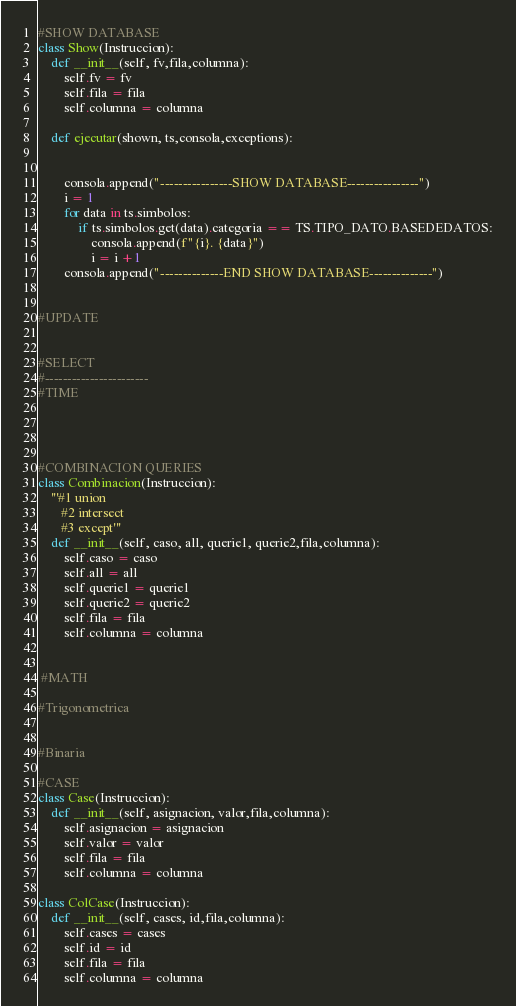<code> <loc_0><loc_0><loc_500><loc_500><_Python_>

#SHOW DATABASE
class Show(Instruccion):
    def __init__(self, fv,fila,columna):
        self.fv = fv
        self.fila = fila
        self.columna = columna

    def ejecutar(shown, ts,consola,exceptions):


        consola.append("----------------SHOW DATABASE----------------")
        i = 1
        for data in ts.simbolos:
            if ts.simbolos.get(data).categoria == TS.TIPO_DATO.BASEDEDATOS:
                consola.append(f"{i}. {data}")
                i = i +1
        consola.append("--------------END SHOW DATABASE--------------")


#UPDATE


#SELECT
#-----------------------
#TIME




#COMBINACION QUERIES
class Combinacion(Instruccion):
    '''#1 union
       #2 intersect
       #3 except'''
    def __init__(self, caso, all, querie1, querie2,fila,columna):
        self.caso = caso
        self.all = all
        self.querie1 = querie1
        self.querie2 = querie2
        self.fila = fila
        self.columna = columna


 #MATH

#Trigonometrica


#Binaria

#CASE
class Case(Instruccion):
    def __init__(self, asignacion, valor,fila,columna):
        self.asignacion = asignacion
        self.valor = valor
        self.fila = fila
        self.columna = columna

class ColCase(Instruccion):
    def __init__(self, cases, id,fila,columna):
        self.cases = cases
        self.id = id
        self.fila = fila
        self.columna = columna

</code> 